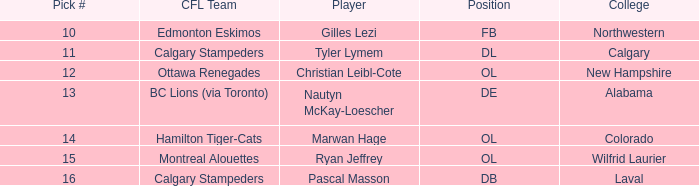What is the pick number for Northwestern college? 10.0. 